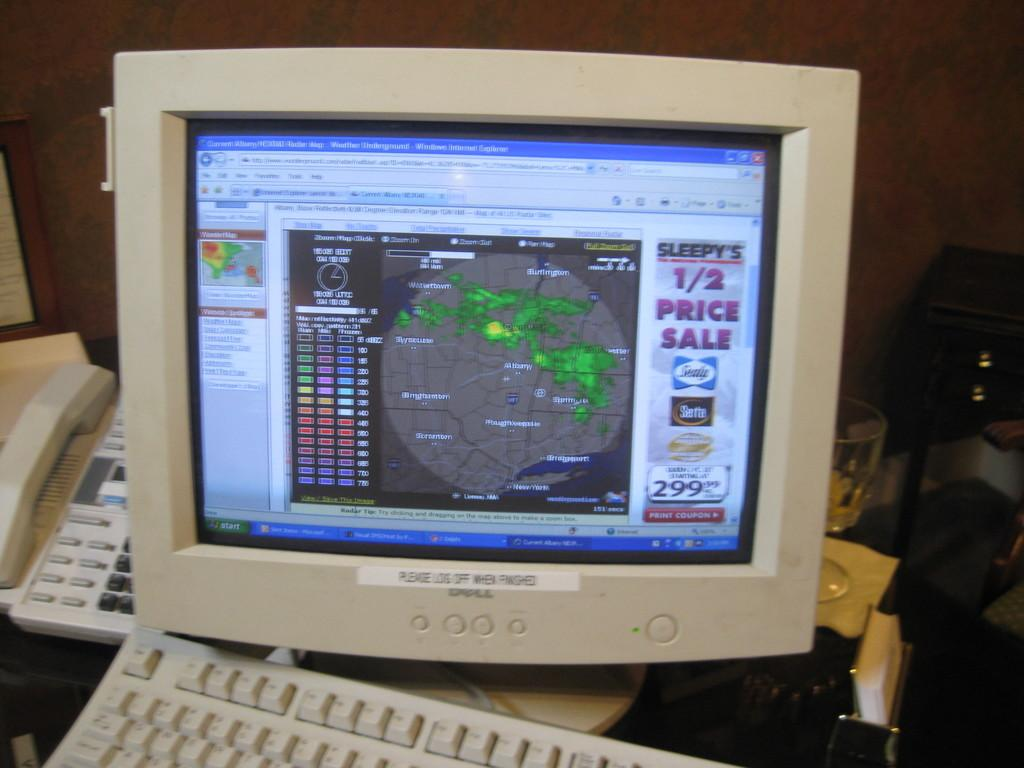<image>
Relay a brief, clear account of the picture shown. an advertisement with a half price sale on a computer screen 